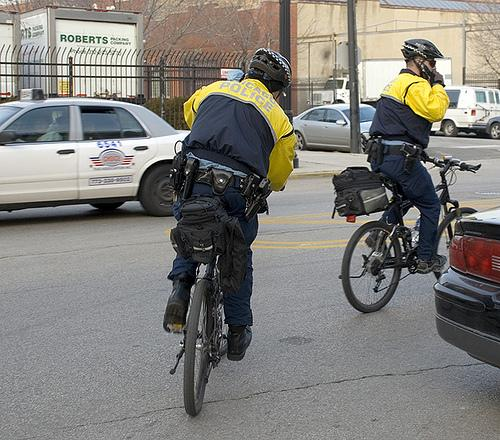What profession are the men on bikes? police 